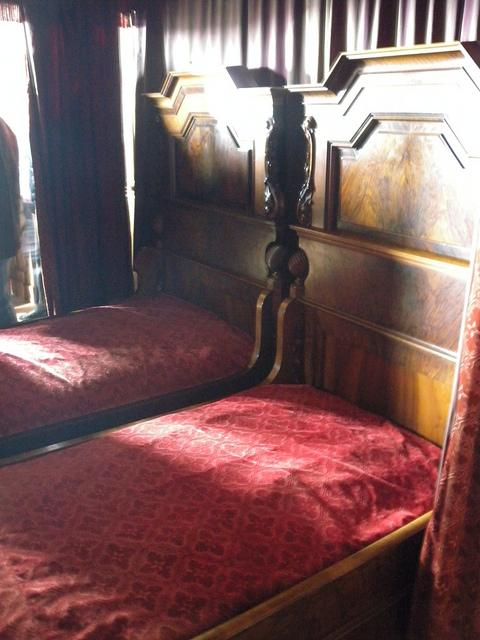What are the two areas decorated with red sheets used for? Please explain your reasoning. sleeping. They are twin beds. 